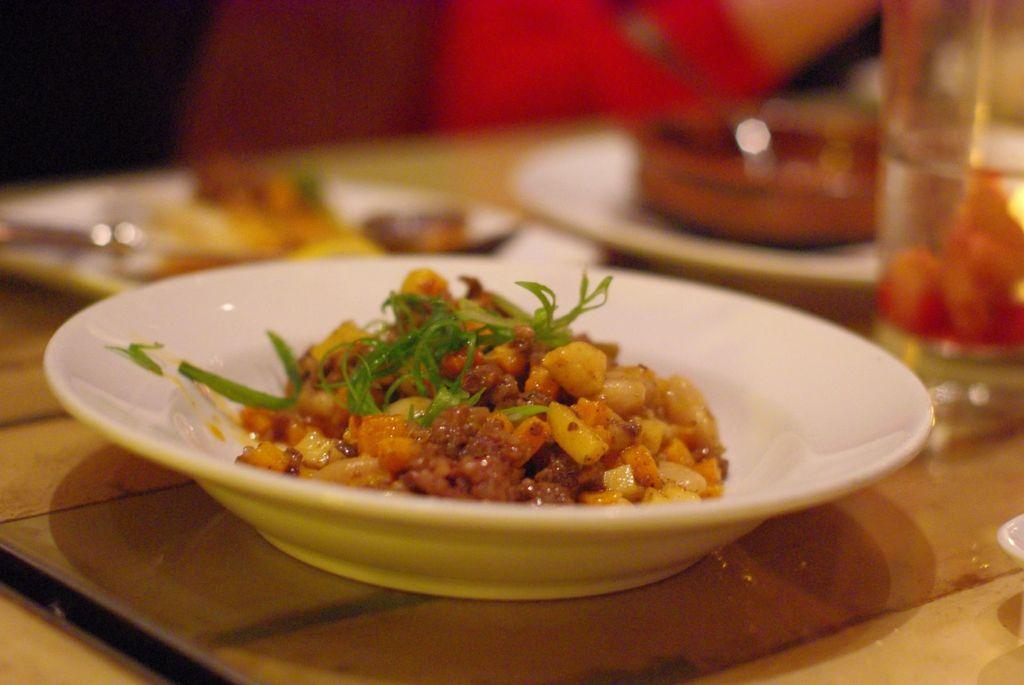What type of food is on the plate in the image? There is a corn dish on a plate in the image. What else is on the plate with the corn dish? There are leaves on the plate with the corn dish. Where is the plate with the corn dish located? The plate is on a dining table. How many plates with food are there in the image? There are two plates with food beside the plate with the corn dish. What is the liquid-holding container in the image? There is a water jug in the image. Can you describe the presence of a person in the image? There appears to be a person in the background of the image. What type of dress is the yam wearing in the image? There is no yam present in the image, and therefore no dress or yam can be observed. 